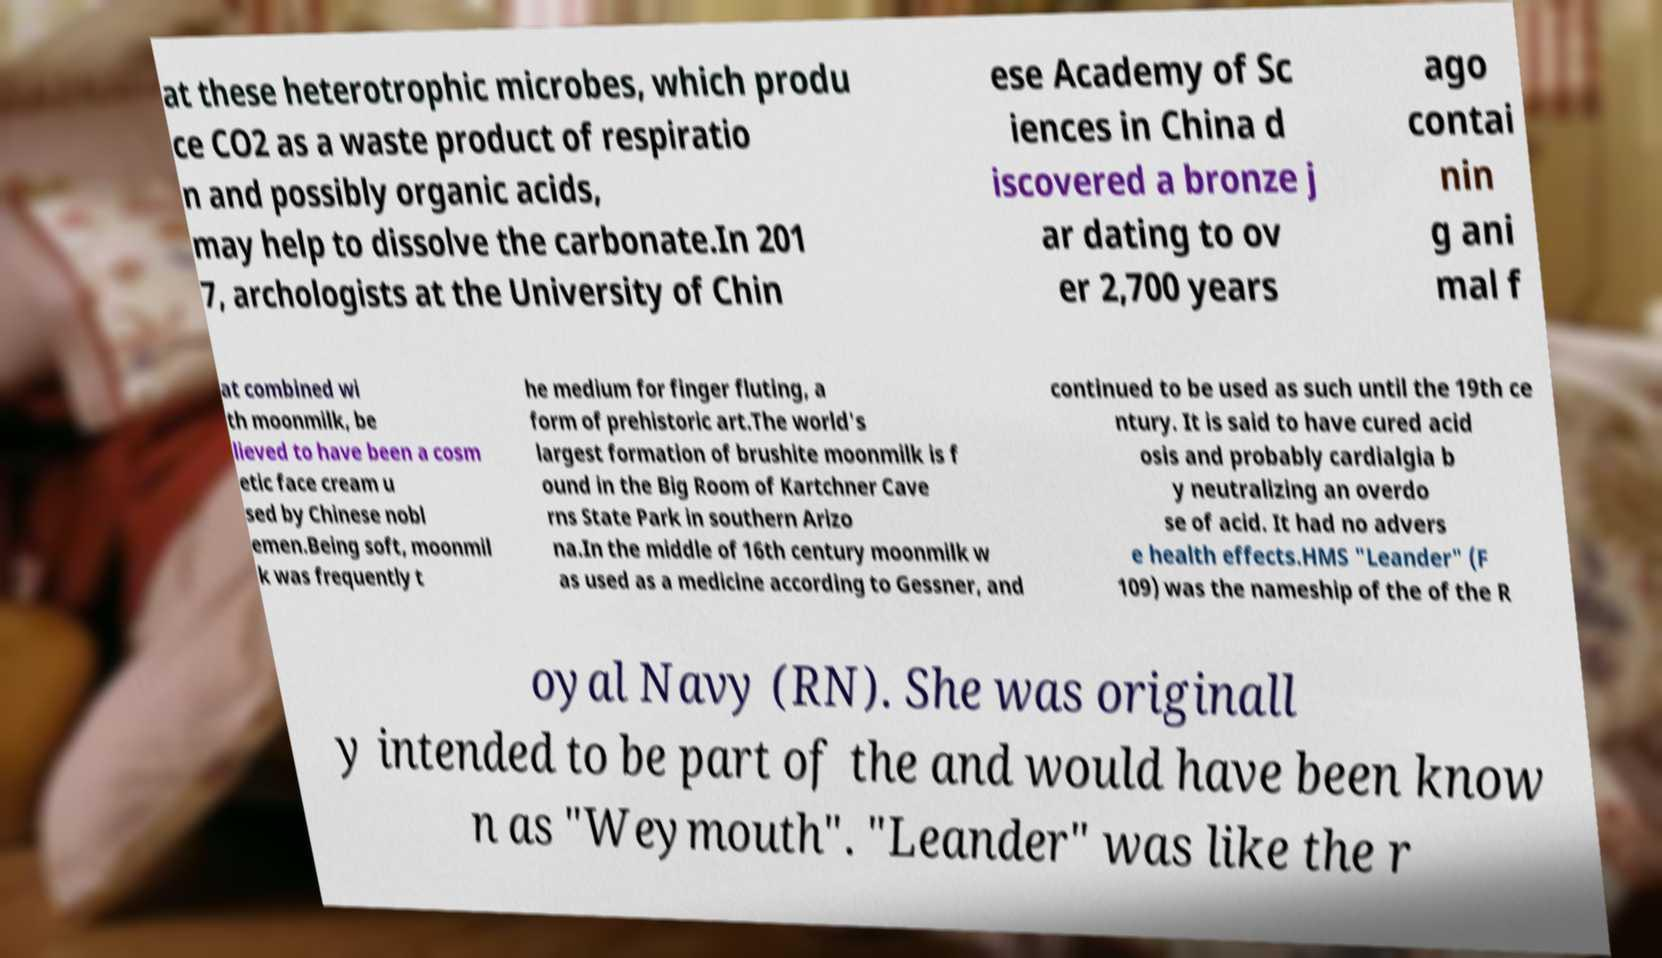For documentation purposes, I need the text within this image transcribed. Could you provide that? at these heterotrophic microbes, which produ ce CO2 as a waste product of respiratio n and possibly organic acids, may help to dissolve the carbonate.In 201 7, archologists at the University of Chin ese Academy of Sc iences in China d iscovered a bronze j ar dating to ov er 2,700 years ago contai nin g ani mal f at combined wi th moonmilk, be lieved to have been a cosm etic face cream u sed by Chinese nobl emen.Being soft, moonmil k was frequently t he medium for finger fluting, a form of prehistoric art.The world's largest formation of brushite moonmilk is f ound in the Big Room of Kartchner Cave rns State Park in southern Arizo na.In the middle of 16th century moonmilk w as used as a medicine according to Gessner, and continued to be used as such until the 19th ce ntury. It is said to have cured acid osis and probably cardialgia b y neutralizing an overdo se of acid. It had no advers e health effects.HMS "Leander" (F 109) was the nameship of the of the R oyal Navy (RN). She was originall y intended to be part of the and would have been know n as "Weymouth". "Leander" was like the r 